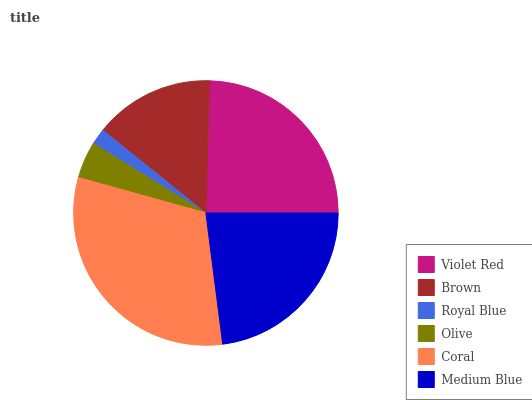Is Royal Blue the minimum?
Answer yes or no. Yes. Is Coral the maximum?
Answer yes or no. Yes. Is Brown the minimum?
Answer yes or no. No. Is Brown the maximum?
Answer yes or no. No. Is Violet Red greater than Brown?
Answer yes or no. Yes. Is Brown less than Violet Red?
Answer yes or no. Yes. Is Brown greater than Violet Red?
Answer yes or no. No. Is Violet Red less than Brown?
Answer yes or no. No. Is Medium Blue the high median?
Answer yes or no. Yes. Is Brown the low median?
Answer yes or no. Yes. Is Royal Blue the high median?
Answer yes or no. No. Is Olive the low median?
Answer yes or no. No. 